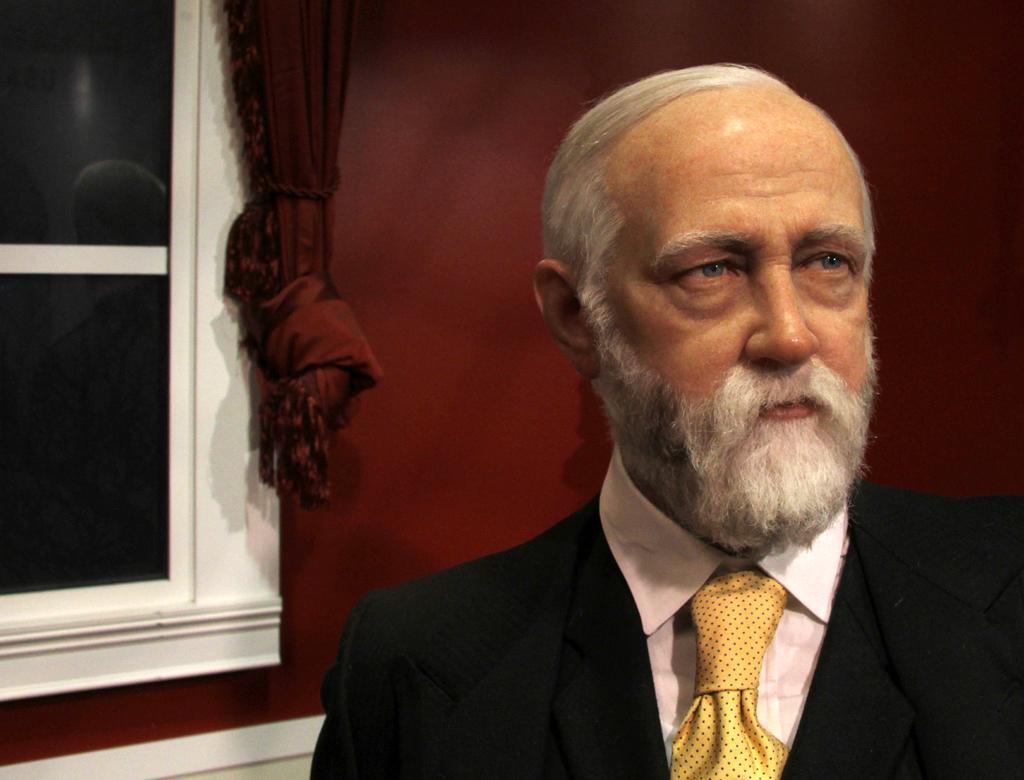How would you summarize this image in a sentence or two? In this image we can see a man and in the background we can see wall, window and curtain. 